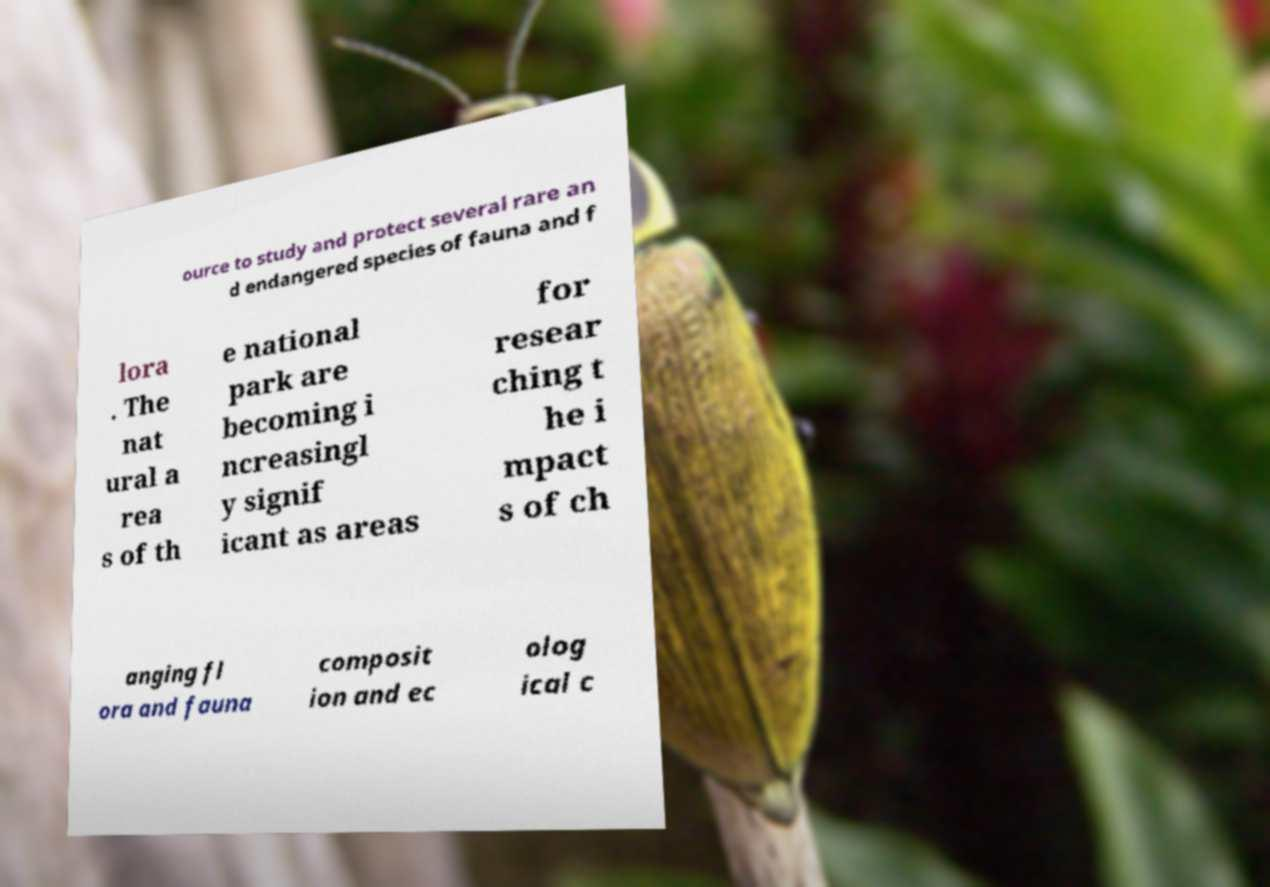For documentation purposes, I need the text within this image transcribed. Could you provide that? ource to study and protect several rare an d endangered species of fauna and f lora . The nat ural a rea s of th e national park are becoming i ncreasingl y signif icant as areas for resear ching t he i mpact s of ch anging fl ora and fauna composit ion and ec olog ical c 